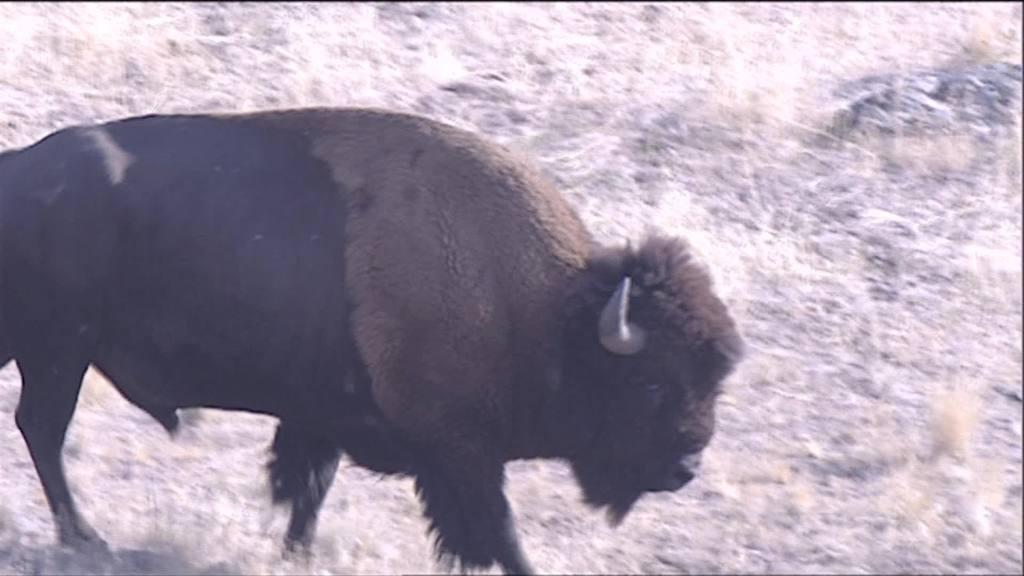What type of animal is in the image? The animal in the image has black and brown coloring. Can you describe the animal's appearance? The animal has black and brown coloring. What can be seen in the background of the image? There are dried trees visible in the image. What type of pies are being sold in the image? There are no pies present in the image; it features an animal with black and brown coloring and dried trees in the background. What industry is depicted in the image? The image does not depict any specific industry; it features an animal and dried trees. 